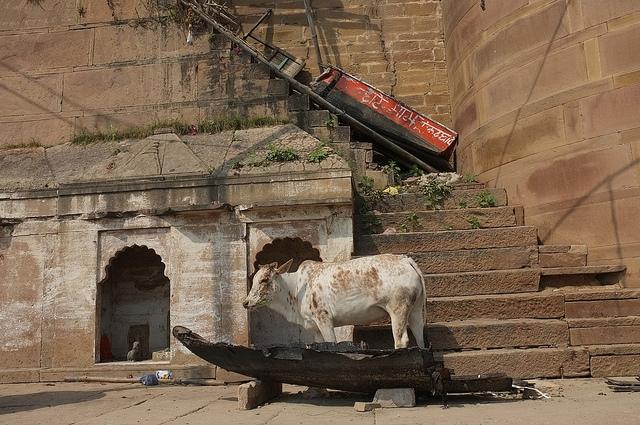Is this a normal place for a cow to be?
Short answer required. No. What color is the cow?
Keep it brief. White. What is the cow standing on?
Keep it brief. Boat. 